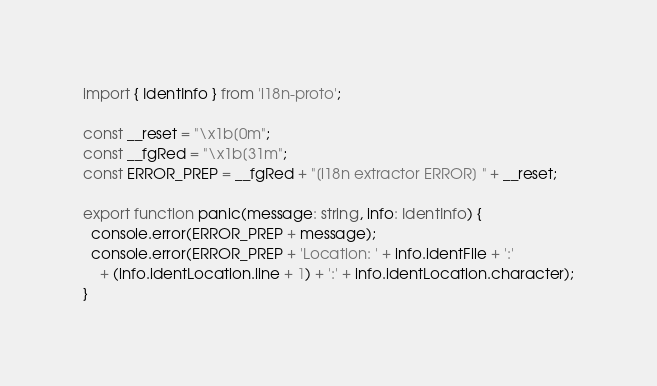<code> <loc_0><loc_0><loc_500><loc_500><_TypeScript_>import { IdentInfo } from 'i18n-proto';

const __reset = "\x1b[0m";
const __fgRed = "\x1b[31m";
const ERROR_PREP = __fgRed + "[i18n extractor ERROR] " + __reset;

export function panic(message: string, info: IdentInfo) {
  console.error(ERROR_PREP + message);
  console.error(ERROR_PREP + 'Location: ' + info.identFile + ':'
    + (info.identLocation.line + 1) + ':' + info.identLocation.character);
}
</code> 